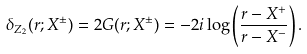<formula> <loc_0><loc_0><loc_500><loc_500>\delta _ { Z _ { 2 } } ( r ; X ^ { \pm } ) = 2 G ( r ; X ^ { \pm } ) = - 2 i \log \left ( \frac { r - X ^ { + } } { r - X ^ { - } } \right ) .</formula> 